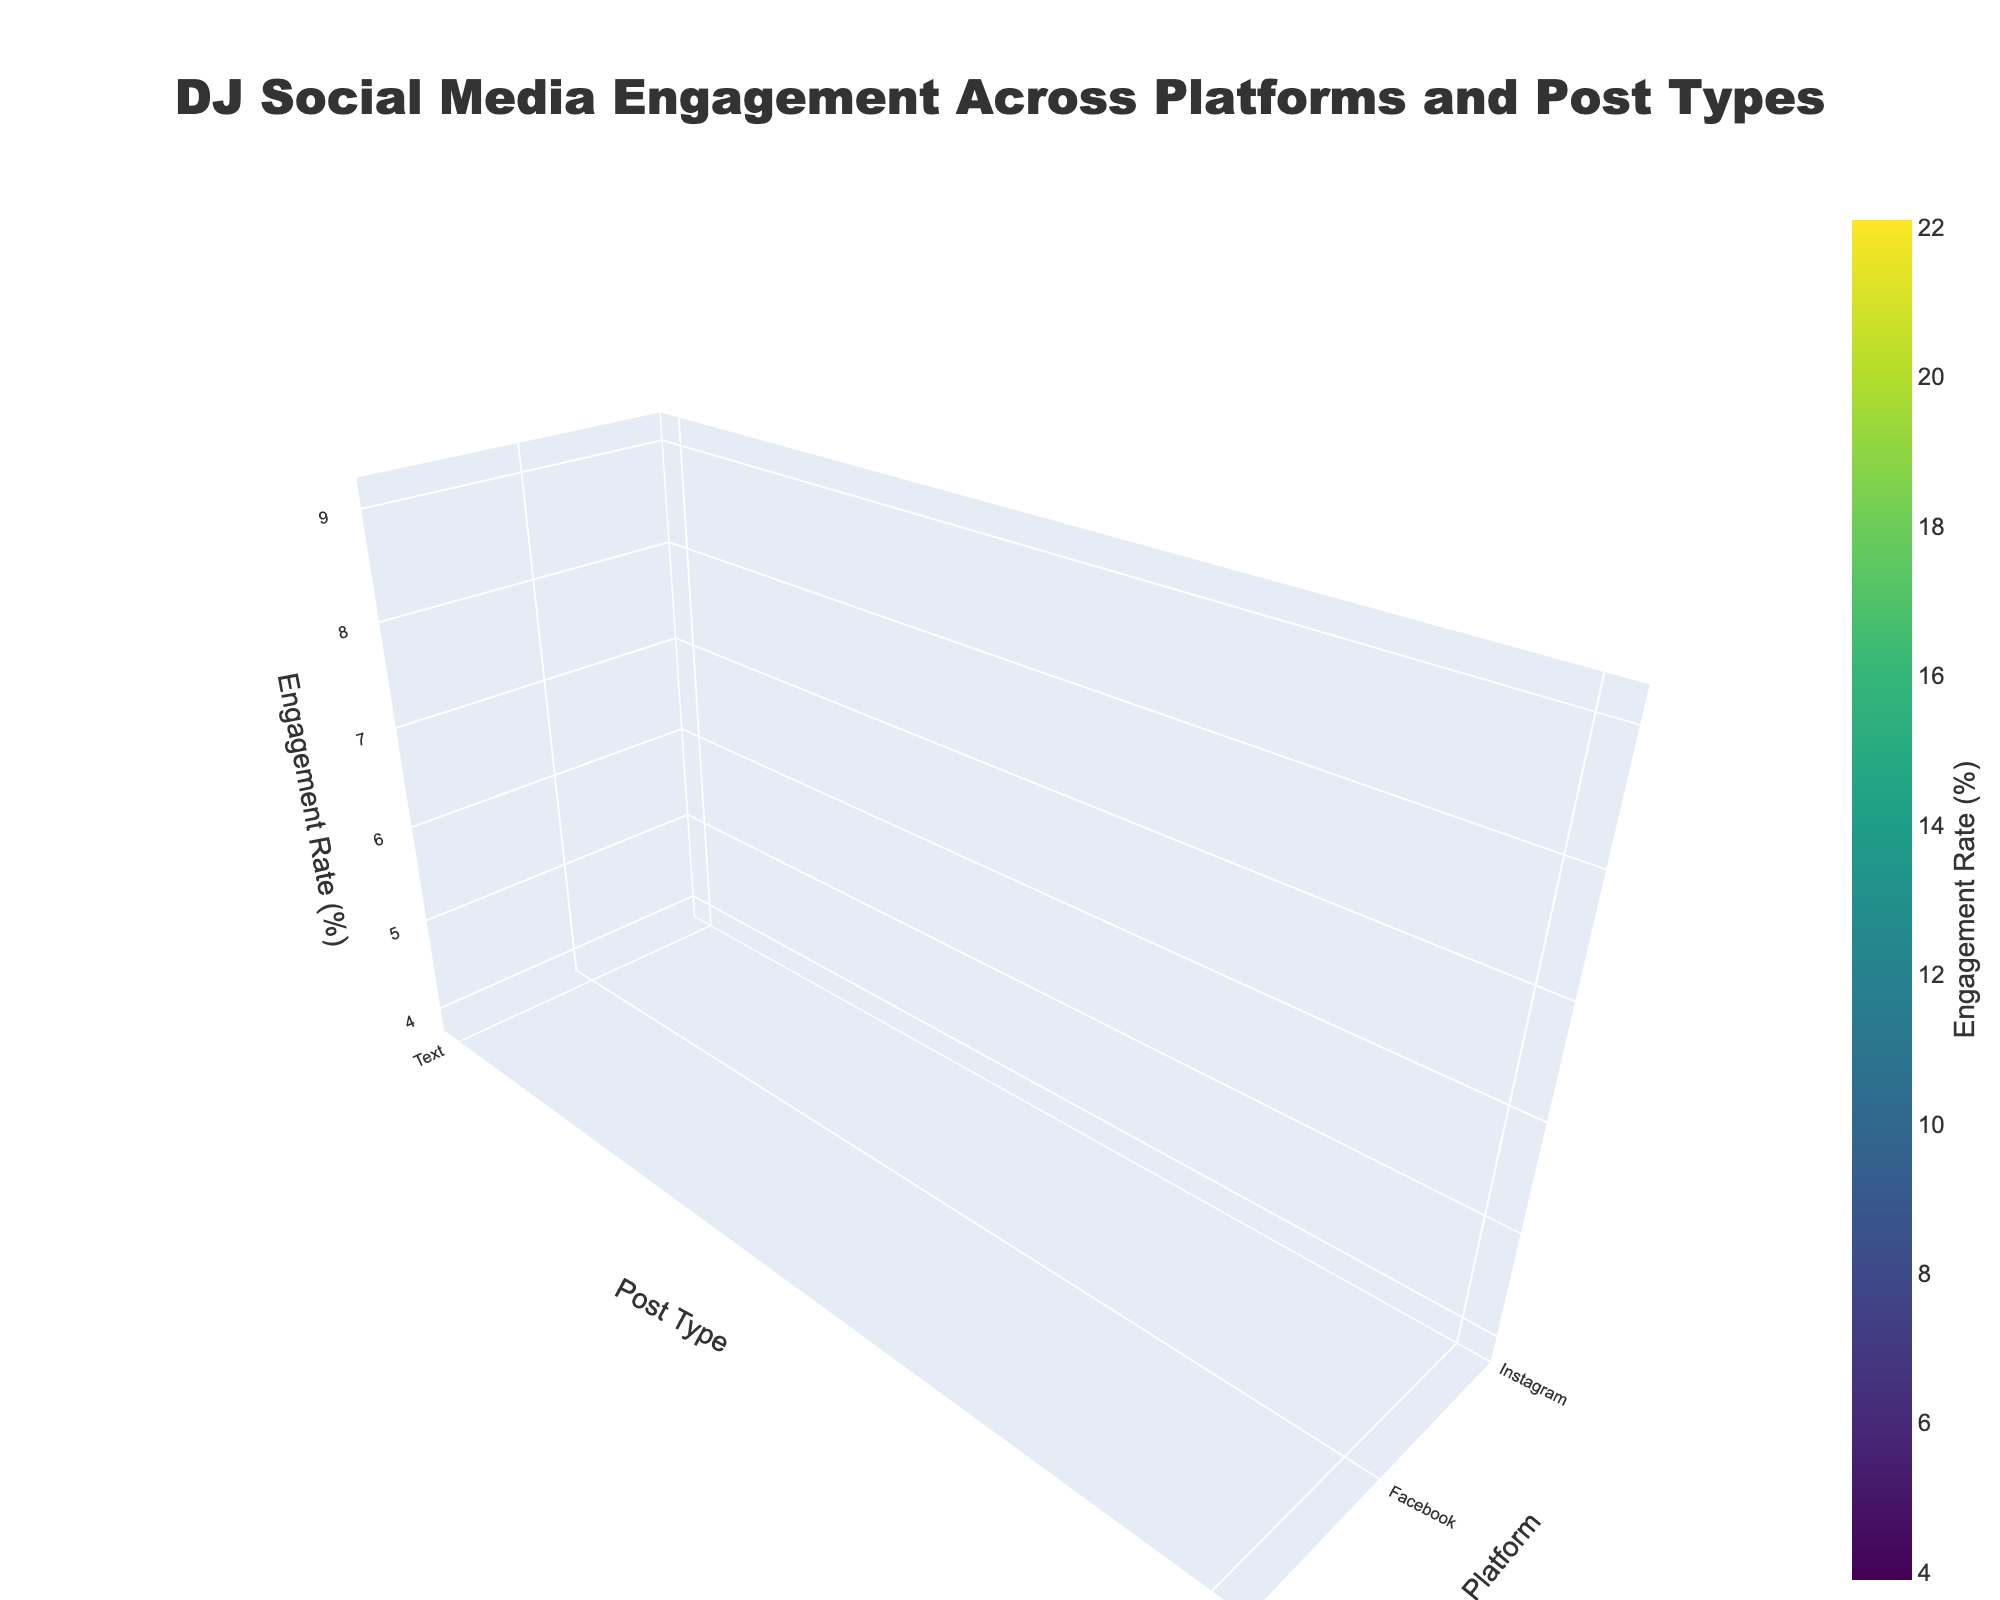What is the title of the plot? The title of the plot can be found at the top center of the figure. It reads "DJ Social Media Engagement Across Platforms and Post Types."
Answer: DJ Social Media Engagement Across Platforms and Post Types What are the axes titles for the x-axis, y-axis, and z-axis? The x-axis title can be found at the bottom of the plot and is "Post Type." The y-axis title is along the left side and reads "Platform." The z-axis title, which is vertical, is "Engagement Rate (%)".
Answer: Post Type, Platform, Engagement Rate (%) What color scale is used in the plot? The color scale used for the engagement rate is "Viridis," evidenced by the green to purple gradient shown.
Answer: Viridis What is the average engagement rate for Instagram post types? The engagement rates for Instagram are 8.2 (Photo), 12.5 (Video), 6.8 (Story), and 15.3 (Reel). Adding these rates gives 8.2 + 12.5 + 6.8 + 15.3 = 42.8, and averaging them is 42.8/4 = 10.7.
Answer: 10.7 What is the difference in engagement rates between the highest and lowest post types for YouTube? The engagement rates for YouTube are 13.8 (Music Video), 16.2 (Live Performance), and 10.5 (Behind the Scenes). The highest rate is 16.2, and the lowest is 10.5. The difference is 16.2 - 10.5 = 5.7.
Answer: 5.7 Which platform has the highest engagement rate and for which post type? By looking at the peak values in the 3D plot, TikTok's Challenge post type has the highest engagement rate of 22.1.
Answer: TikTok, Challenge Which platform has the lowest overall engagement rate and for which post type? The lowest overall engagement rate is on Facebook for Text posts, which is 3.9%. This can be identified by the lowest point in the 3D surface.
Answer: Facebook, Text How does the surface shape differ between platforms? The surface plot's shape varies, with some platforms like TikTok and Twitch having steeper peaks and valleys, indicating high variation in engagement rates, while others like Facebook have smoother surfaces, indicating less variation.
Answer: Steep for TikTok and Twitch, smoother for Facebook Which post type shows the most consistent engagement rate across platforms? By observing the heights of the 3D surface for different post types, Photos (particularly Facebook and Instagram) seem to have less variation in engagement rates across different platforms.
Answer: Photo 